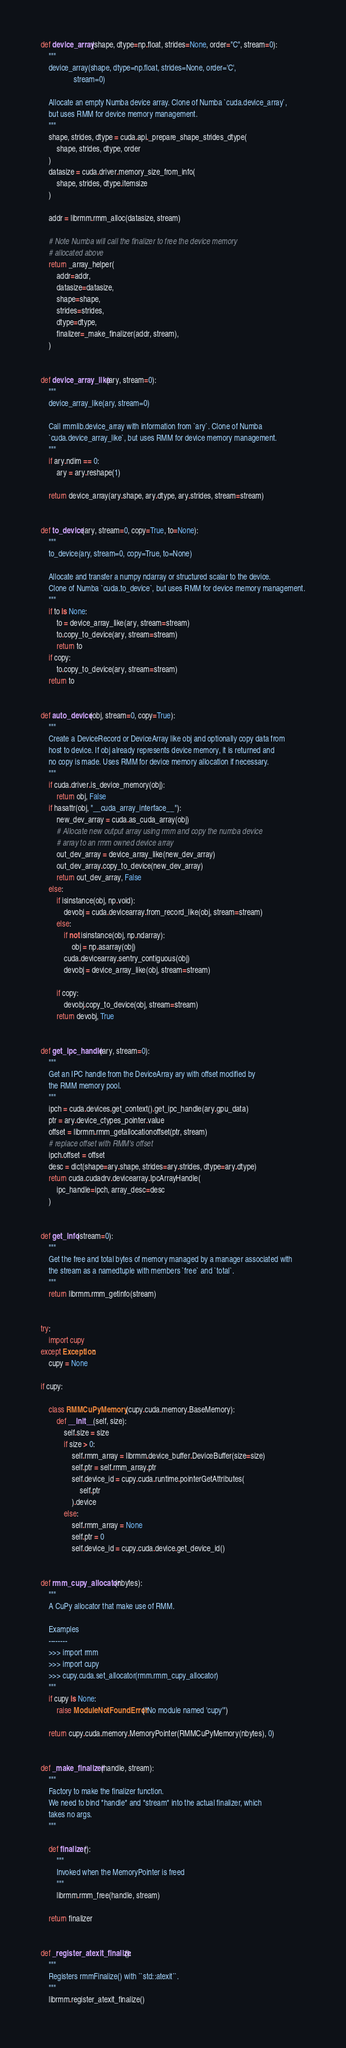Convert code to text. <code><loc_0><loc_0><loc_500><loc_500><_Python_>
def device_array(shape, dtype=np.float, strides=None, order="C", stream=0):
    """
    device_array(shape, dtype=np.float, strides=None, order='C',
                 stream=0)

    Allocate an empty Numba device array. Clone of Numba `cuda.device_array`,
    but uses RMM for device memory management.
    """
    shape, strides, dtype = cuda.api._prepare_shape_strides_dtype(
        shape, strides, dtype, order
    )
    datasize = cuda.driver.memory_size_from_info(
        shape, strides, dtype.itemsize
    )

    addr = librmm.rmm_alloc(datasize, stream)

    # Note Numba will call the finalizer to free the device memory
    # allocated above
    return _array_helper(
        addr=addr,
        datasize=datasize,
        shape=shape,
        strides=strides,
        dtype=dtype,
        finalizer=_make_finalizer(addr, stream),
    )


def device_array_like(ary, stream=0):
    """
    device_array_like(ary, stream=0)

    Call rmmlib.device_array with information from `ary`. Clone of Numba
    `cuda.device_array_like`, but uses RMM for device memory management.
    """
    if ary.ndim == 0:
        ary = ary.reshape(1)

    return device_array(ary.shape, ary.dtype, ary.strides, stream=stream)


def to_device(ary, stream=0, copy=True, to=None):
    """
    to_device(ary, stream=0, copy=True, to=None)

    Allocate and transfer a numpy ndarray or structured scalar to the device.
    Clone of Numba `cuda.to_device`, but uses RMM for device memory management.
    """
    if to is None:
        to = device_array_like(ary, stream=stream)
        to.copy_to_device(ary, stream=stream)
        return to
    if copy:
        to.copy_to_device(ary, stream=stream)
    return to


def auto_device(obj, stream=0, copy=True):
    """
    Create a DeviceRecord or DeviceArray like obj and optionally copy data from
    host to device. If obj already represents device memory, it is returned and
    no copy is made. Uses RMM for device memory allocation if necessary.
    """
    if cuda.driver.is_device_memory(obj):
        return obj, False
    if hasattr(obj, "__cuda_array_interface__"):
        new_dev_array = cuda.as_cuda_array(obj)
        # Allocate new output array using rmm and copy the numba device
        # array to an rmm owned device array
        out_dev_array = device_array_like(new_dev_array)
        out_dev_array.copy_to_device(new_dev_array)
        return out_dev_array, False
    else:
        if isinstance(obj, np.void):
            devobj = cuda.devicearray.from_record_like(obj, stream=stream)
        else:
            if not isinstance(obj, np.ndarray):
                obj = np.asarray(obj)
            cuda.devicearray.sentry_contiguous(obj)
            devobj = device_array_like(obj, stream=stream)

        if copy:
            devobj.copy_to_device(obj, stream=stream)
        return devobj, True


def get_ipc_handle(ary, stream=0):
    """
    Get an IPC handle from the DeviceArray ary with offset modified by
    the RMM memory pool.
    """
    ipch = cuda.devices.get_context().get_ipc_handle(ary.gpu_data)
    ptr = ary.device_ctypes_pointer.value
    offset = librmm.rmm_getallocationoffset(ptr, stream)
    # replace offset with RMM's offset
    ipch.offset = offset
    desc = dict(shape=ary.shape, strides=ary.strides, dtype=ary.dtype)
    return cuda.cudadrv.devicearray.IpcArrayHandle(
        ipc_handle=ipch, array_desc=desc
    )


def get_info(stream=0):
    """
    Get the free and total bytes of memory managed by a manager associated with
    the stream as a namedtuple with members `free` and `total`.
    """
    return librmm.rmm_getinfo(stream)


try:
    import cupy
except Exception:
    cupy = None

if cupy:

    class RMMCuPyMemory(cupy.cuda.memory.BaseMemory):
        def __init__(self, size):
            self.size = size
            if size > 0:
                self.rmm_array = librmm.device_buffer.DeviceBuffer(size=size)
                self.ptr = self.rmm_array.ptr
                self.device_id = cupy.cuda.runtime.pointerGetAttributes(
                    self.ptr
                ).device
            else:
                self.rmm_array = None
                self.ptr = 0
                self.device_id = cupy.cuda.device.get_device_id()


def rmm_cupy_allocator(nbytes):
    """
    A CuPy allocator that make use of RMM.

    Examples
    --------
    >>> import rmm
    >>> import cupy
    >>> cupy.cuda.set_allocator(rmm.rmm_cupy_allocator)
    """
    if cupy is None:
        raise ModuleNotFoundError("No module named 'cupy'")

    return cupy.cuda.memory.MemoryPointer(RMMCuPyMemory(nbytes), 0)


def _make_finalizer(handle, stream):
    """
    Factory to make the finalizer function.
    We need to bind *handle* and *stream* into the actual finalizer, which
    takes no args.
    """

    def finalizer():
        """
        Invoked when the MemoryPointer is freed
        """
        librmm.rmm_free(handle, stream)

    return finalizer


def _register_atexit_finalize():
    """
    Registers rmmFinalize() with ``std::atexit``.
    """
    librmm.register_atexit_finalize()
</code> 